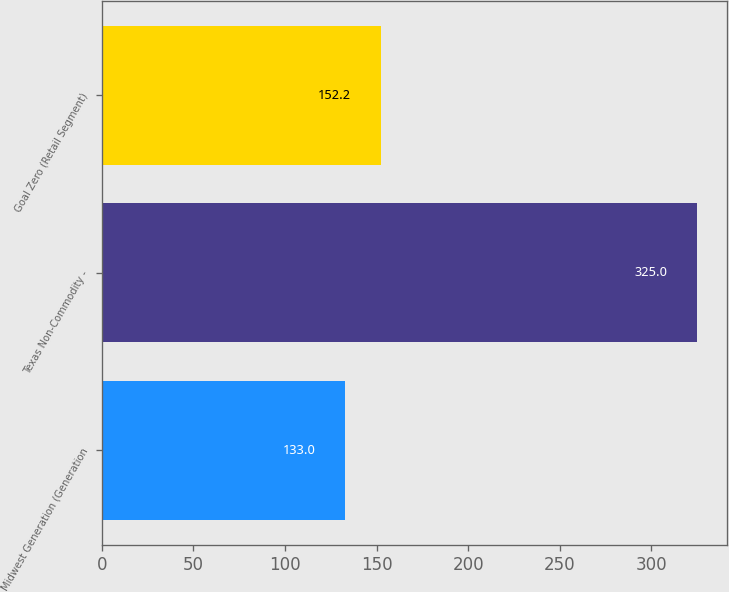Convert chart to OTSL. <chart><loc_0><loc_0><loc_500><loc_500><bar_chart><fcel>Midwest Generation (Generation<fcel>Texas Non-Commodity -<fcel>Goal Zero (Retail Segment)<nl><fcel>133<fcel>325<fcel>152.2<nl></chart> 